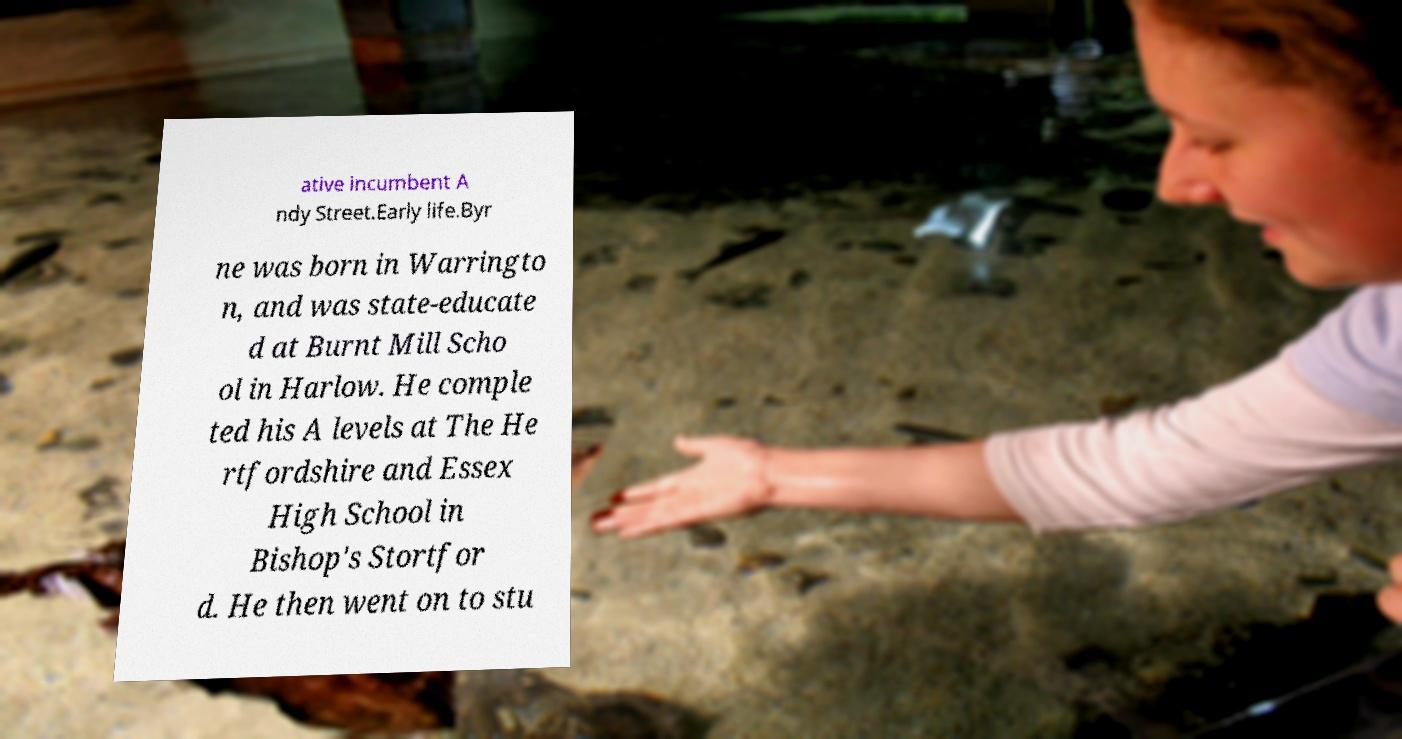I need the written content from this picture converted into text. Can you do that? ative incumbent A ndy Street.Early life.Byr ne was born in Warringto n, and was state-educate d at Burnt Mill Scho ol in Harlow. He comple ted his A levels at The He rtfordshire and Essex High School in Bishop's Stortfor d. He then went on to stu 